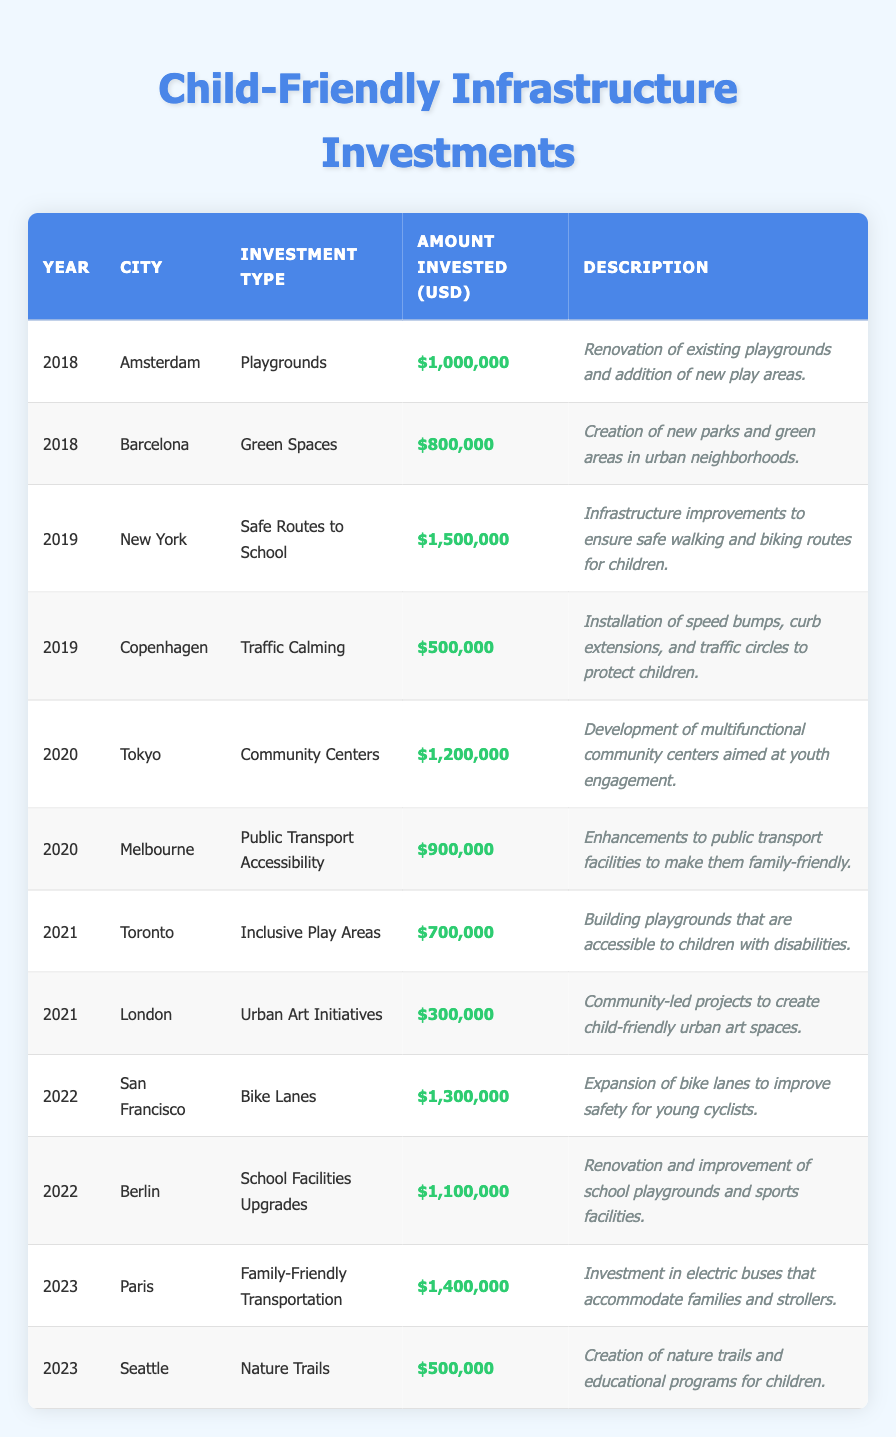What is the total investment amount in 2022? In 2022, the investments were made in San Francisco ($1,300,000) and Berlin ($1,100,000). Adding these amounts gives us a total of $1,300,000 + $1,100,000 = $2,400,000.
Answer: $2,400,000 Which city received the highest investment in 2019? The investments in 2019 were $1,500,000 in New York and $500,000 in Copenhagen. New York received the highest investment of $1,500,000.
Answer: New York How many cities invested in playground-related infrastructure? The cities that invested in playgrounds are Amsterdam in 2018, Toronto in 2021 (for inclusive play areas), and Berlin in 2022 (for school facilities upgrades, which includes playground renovation). This gives us three relevant cities: Amsterdam, Toronto, and Berlin.
Answer: 3 Did any city invest in community centers in 2020? Yes, Tokyo invested $1,200,000 in community centers in 2020.
Answer: Yes Which investment type had the lowest total amount invested across all years? The lowest investment type is Urban Art Initiatives with an investment of $300,000 in London in 2021.
Answer: Urban Art Initiatives What is the average amount invested in child-friendly infrastructure per year from 2018 to 2023? First, calculate the total investments: $1,000,000 + $800,000 + $1,500,000 + $500,000 + $1,200,000 + $900,000 + $700,000 + $300,000 + $1,300,000 + $1,100,000 + $1,400,000 + $500,000 = $11,800,000. There are 6 years, so the average is $11,800,000 / 6 = $1,966,666.67.
Answer: $1,966,666.67 Which year had the highest overall investment in child-friendly infrastructure? The years with the highest investment amounts are 2019 ($2,000,000 from New York and Copenhagen combined) and 2023 ($1,900,000 from Paris and Seattle combined). 2019 had the highest overall investment at $2,000,000.
Answer: 2019 How many investment types were recorded in total? The investment types listed are Playgrounds, Green Spaces, Safe Routes to School, Traffic Calming, Community Centers, Public Transport Accessibility, Inclusive Play Areas, Urban Art Initiatives, Bike Lanes, School Facilities Upgrades, Family-Friendly Transportation, and Nature Trails. This totals 12 unique investment types.
Answer: 12 Which cities had investments specifically for safe routes to school? Only New York in 2019 invested in Safe Routes to School for an amount of $1,500,000.
Answer: New York Was there an investment in nature trails in 2021? No, in 2021, investments were made in Toronto (Inclusive Play Areas) and London (Urban Art Initiatives), but none were made for nature trails.
Answer: No What was the investment amount for public transport accessibility in Melbourne? Melbourne invested $900,000 for public transport accessibility in 2020.
Answer: $900,000 